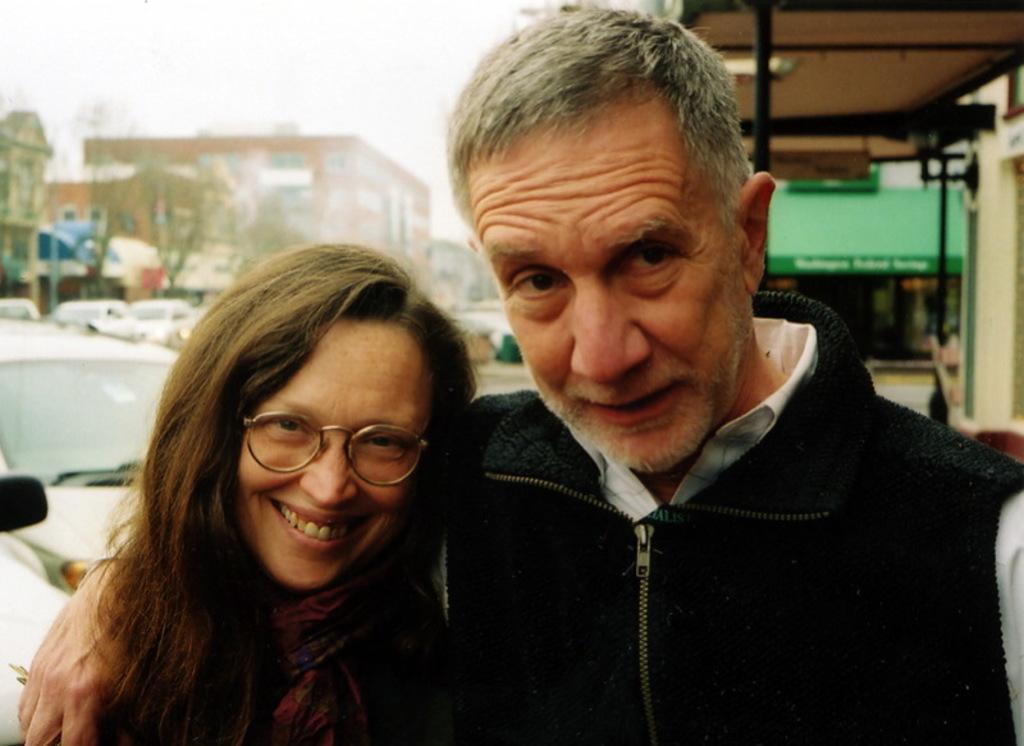In one or two sentences, can you explain what this image depicts? In the center of the image we can see two persons are standing and they are smiling, which we can see on their faces. And the right side person is wearing glasses. In the background, we can see the sky, buildings, tents, poles, trees, vehicles and a few other objects. 